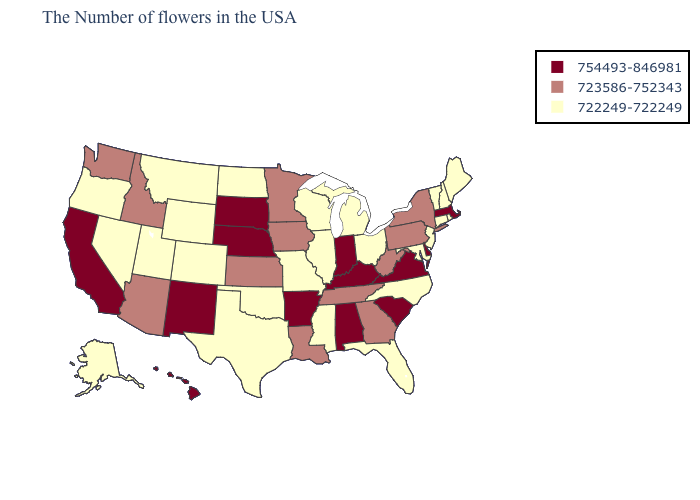Does Massachusetts have the highest value in the Northeast?
Keep it brief. Yes. Name the states that have a value in the range 754493-846981?
Short answer required. Massachusetts, Delaware, Virginia, South Carolina, Kentucky, Indiana, Alabama, Arkansas, Nebraska, South Dakota, New Mexico, California, Hawaii. Name the states that have a value in the range 722249-722249?
Be succinct. Maine, Rhode Island, New Hampshire, Vermont, Connecticut, New Jersey, Maryland, North Carolina, Ohio, Florida, Michigan, Wisconsin, Illinois, Mississippi, Missouri, Oklahoma, Texas, North Dakota, Wyoming, Colorado, Utah, Montana, Nevada, Oregon, Alaska. Does Oklahoma have a higher value than Ohio?
Quick response, please. No. What is the lowest value in states that border Louisiana?
Quick response, please. 722249-722249. Which states have the lowest value in the MidWest?
Quick response, please. Ohio, Michigan, Wisconsin, Illinois, Missouri, North Dakota. Name the states that have a value in the range 754493-846981?
Write a very short answer. Massachusetts, Delaware, Virginia, South Carolina, Kentucky, Indiana, Alabama, Arkansas, Nebraska, South Dakota, New Mexico, California, Hawaii. What is the lowest value in states that border Oklahoma?
Keep it brief. 722249-722249. What is the value of Virginia?
Short answer required. 754493-846981. What is the value of New York?
Give a very brief answer. 723586-752343. Among the states that border Tennessee , does Arkansas have the highest value?
Write a very short answer. Yes. Among the states that border Oregon , which have the highest value?
Keep it brief. California. Among the states that border Nebraska , which have the lowest value?
Quick response, please. Missouri, Wyoming, Colorado. Name the states that have a value in the range 723586-752343?
Short answer required. New York, Pennsylvania, West Virginia, Georgia, Tennessee, Louisiana, Minnesota, Iowa, Kansas, Arizona, Idaho, Washington. What is the highest value in states that border Nebraska?
Concise answer only. 754493-846981. 